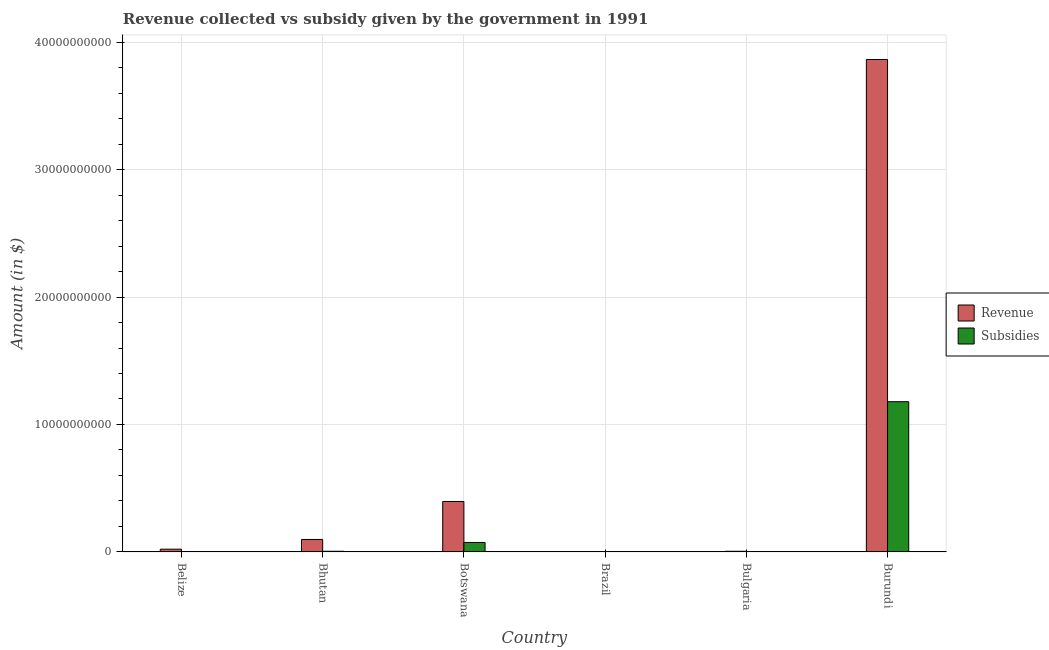How many different coloured bars are there?
Ensure brevity in your answer.  2. How many groups of bars are there?
Your response must be concise. 6. Are the number of bars per tick equal to the number of legend labels?
Provide a short and direct response. Yes. Are the number of bars on each tick of the X-axis equal?
Give a very brief answer. Yes. What is the label of the 1st group of bars from the left?
Your answer should be very brief. Belize. In how many cases, is the number of bars for a given country not equal to the number of legend labels?
Keep it short and to the point. 0. What is the amount of subsidies given in Bhutan?
Keep it short and to the point. 5.12e+07. Across all countries, what is the maximum amount of subsidies given?
Offer a very short reply. 1.18e+1. Across all countries, what is the minimum amount of revenue collected?
Give a very brief answer. 1.25e+07. In which country was the amount of revenue collected maximum?
Ensure brevity in your answer.  Burundi. What is the total amount of revenue collected in the graph?
Provide a short and direct response. 4.38e+1. What is the difference between the amount of revenue collected in Belize and that in Burundi?
Ensure brevity in your answer.  -3.84e+1. What is the difference between the amount of subsidies given in Botswana and the amount of revenue collected in Belize?
Your answer should be very brief. 5.28e+08. What is the average amount of subsidies given per country?
Make the answer very short. 2.10e+09. What is the difference between the amount of revenue collected and amount of subsidies given in Bhutan?
Give a very brief answer. 9.25e+08. What is the ratio of the amount of subsidies given in Belize to that in Botswana?
Your response must be concise. 0.02. Is the amount of subsidies given in Bhutan less than that in Brazil?
Offer a terse response. No. What is the difference between the highest and the second highest amount of subsidies given?
Your answer should be very brief. 1.10e+1. What is the difference between the highest and the lowest amount of revenue collected?
Keep it short and to the point. 3.86e+1. In how many countries, is the amount of subsidies given greater than the average amount of subsidies given taken over all countries?
Make the answer very short. 1. Is the sum of the amount of subsidies given in Bulgaria and Burundi greater than the maximum amount of revenue collected across all countries?
Offer a terse response. No. What does the 1st bar from the left in Bhutan represents?
Your answer should be compact. Revenue. What does the 2nd bar from the right in Botswana represents?
Your answer should be very brief. Revenue. How many bars are there?
Offer a very short reply. 12. Are all the bars in the graph horizontal?
Offer a terse response. No. Are the values on the major ticks of Y-axis written in scientific E-notation?
Give a very brief answer. No. Does the graph contain grids?
Keep it short and to the point. Yes. Where does the legend appear in the graph?
Offer a terse response. Center right. What is the title of the graph?
Provide a succinct answer. Revenue collected vs subsidy given by the government in 1991. Does "International Visitors" appear as one of the legend labels in the graph?
Ensure brevity in your answer.  No. What is the label or title of the X-axis?
Give a very brief answer. Country. What is the label or title of the Y-axis?
Give a very brief answer. Amount (in $). What is the Amount (in $) of Revenue in Belize?
Your answer should be very brief. 2.14e+08. What is the Amount (in $) in Subsidies in Belize?
Ensure brevity in your answer.  1.41e+07. What is the Amount (in $) in Revenue in Bhutan?
Provide a short and direct response. 9.76e+08. What is the Amount (in $) of Subsidies in Bhutan?
Provide a short and direct response. 5.12e+07. What is the Amount (in $) of Revenue in Botswana?
Your response must be concise. 3.96e+09. What is the Amount (in $) of Subsidies in Botswana?
Give a very brief answer. 7.42e+08. What is the Amount (in $) in Revenue in Brazil?
Keep it short and to the point. 1.25e+07. What is the Amount (in $) in Subsidies in Brazil?
Offer a terse response. 7.89e+06. What is the Amount (in $) of Revenue in Bulgaria?
Provide a short and direct response. 4.94e+07. What is the Amount (in $) in Subsidies in Bulgaria?
Give a very brief answer. 2.72e+07. What is the Amount (in $) of Revenue in Burundi?
Provide a succinct answer. 3.86e+1. What is the Amount (in $) in Subsidies in Burundi?
Keep it short and to the point. 1.18e+1. Across all countries, what is the maximum Amount (in $) of Revenue?
Make the answer very short. 3.86e+1. Across all countries, what is the maximum Amount (in $) in Subsidies?
Keep it short and to the point. 1.18e+1. Across all countries, what is the minimum Amount (in $) in Revenue?
Your response must be concise. 1.25e+07. Across all countries, what is the minimum Amount (in $) of Subsidies?
Keep it short and to the point. 7.89e+06. What is the total Amount (in $) of Revenue in the graph?
Provide a succinct answer. 4.38e+1. What is the total Amount (in $) of Subsidies in the graph?
Give a very brief answer. 1.26e+1. What is the difference between the Amount (in $) of Revenue in Belize and that in Bhutan?
Keep it short and to the point. -7.63e+08. What is the difference between the Amount (in $) in Subsidies in Belize and that in Bhutan?
Keep it short and to the point. -3.71e+07. What is the difference between the Amount (in $) of Revenue in Belize and that in Botswana?
Make the answer very short. -3.74e+09. What is the difference between the Amount (in $) in Subsidies in Belize and that in Botswana?
Offer a terse response. -7.28e+08. What is the difference between the Amount (in $) of Revenue in Belize and that in Brazil?
Your response must be concise. 2.01e+08. What is the difference between the Amount (in $) of Subsidies in Belize and that in Brazil?
Ensure brevity in your answer.  6.24e+06. What is the difference between the Amount (in $) in Revenue in Belize and that in Bulgaria?
Offer a terse response. 1.64e+08. What is the difference between the Amount (in $) of Subsidies in Belize and that in Bulgaria?
Provide a short and direct response. -1.31e+07. What is the difference between the Amount (in $) of Revenue in Belize and that in Burundi?
Ensure brevity in your answer.  -3.84e+1. What is the difference between the Amount (in $) in Subsidies in Belize and that in Burundi?
Keep it short and to the point. -1.18e+1. What is the difference between the Amount (in $) in Revenue in Bhutan and that in Botswana?
Give a very brief answer. -2.98e+09. What is the difference between the Amount (in $) in Subsidies in Bhutan and that in Botswana?
Provide a short and direct response. -6.91e+08. What is the difference between the Amount (in $) in Revenue in Bhutan and that in Brazil?
Provide a succinct answer. 9.64e+08. What is the difference between the Amount (in $) in Subsidies in Bhutan and that in Brazil?
Provide a short and direct response. 4.33e+07. What is the difference between the Amount (in $) of Revenue in Bhutan and that in Bulgaria?
Provide a succinct answer. 9.27e+08. What is the difference between the Amount (in $) in Subsidies in Bhutan and that in Bulgaria?
Your response must be concise. 2.40e+07. What is the difference between the Amount (in $) in Revenue in Bhutan and that in Burundi?
Ensure brevity in your answer.  -3.77e+1. What is the difference between the Amount (in $) of Subsidies in Bhutan and that in Burundi?
Your answer should be very brief. -1.17e+1. What is the difference between the Amount (in $) in Revenue in Botswana and that in Brazil?
Offer a terse response. 3.94e+09. What is the difference between the Amount (in $) in Subsidies in Botswana and that in Brazil?
Provide a succinct answer. 7.34e+08. What is the difference between the Amount (in $) of Revenue in Botswana and that in Bulgaria?
Offer a terse response. 3.91e+09. What is the difference between the Amount (in $) of Subsidies in Botswana and that in Bulgaria?
Give a very brief answer. 7.15e+08. What is the difference between the Amount (in $) of Revenue in Botswana and that in Burundi?
Provide a succinct answer. -3.47e+1. What is the difference between the Amount (in $) in Subsidies in Botswana and that in Burundi?
Ensure brevity in your answer.  -1.10e+1. What is the difference between the Amount (in $) of Revenue in Brazil and that in Bulgaria?
Your answer should be compact. -3.69e+07. What is the difference between the Amount (in $) in Subsidies in Brazil and that in Bulgaria?
Offer a very short reply. -1.93e+07. What is the difference between the Amount (in $) in Revenue in Brazil and that in Burundi?
Provide a succinct answer. -3.86e+1. What is the difference between the Amount (in $) in Subsidies in Brazil and that in Burundi?
Make the answer very short. -1.18e+1. What is the difference between the Amount (in $) of Revenue in Bulgaria and that in Burundi?
Provide a succinct answer. -3.86e+1. What is the difference between the Amount (in $) in Subsidies in Bulgaria and that in Burundi?
Your answer should be very brief. -1.18e+1. What is the difference between the Amount (in $) in Revenue in Belize and the Amount (in $) in Subsidies in Bhutan?
Keep it short and to the point. 1.63e+08. What is the difference between the Amount (in $) of Revenue in Belize and the Amount (in $) of Subsidies in Botswana?
Provide a short and direct response. -5.28e+08. What is the difference between the Amount (in $) in Revenue in Belize and the Amount (in $) in Subsidies in Brazil?
Offer a terse response. 2.06e+08. What is the difference between the Amount (in $) of Revenue in Belize and the Amount (in $) of Subsidies in Bulgaria?
Ensure brevity in your answer.  1.87e+08. What is the difference between the Amount (in $) of Revenue in Belize and the Amount (in $) of Subsidies in Burundi?
Keep it short and to the point. -1.16e+1. What is the difference between the Amount (in $) in Revenue in Bhutan and the Amount (in $) in Subsidies in Botswana?
Your response must be concise. 2.34e+08. What is the difference between the Amount (in $) of Revenue in Bhutan and the Amount (in $) of Subsidies in Brazil?
Your response must be concise. 9.69e+08. What is the difference between the Amount (in $) in Revenue in Bhutan and the Amount (in $) in Subsidies in Bulgaria?
Your answer should be compact. 9.49e+08. What is the difference between the Amount (in $) of Revenue in Bhutan and the Amount (in $) of Subsidies in Burundi?
Your response must be concise. -1.08e+1. What is the difference between the Amount (in $) of Revenue in Botswana and the Amount (in $) of Subsidies in Brazil?
Give a very brief answer. 3.95e+09. What is the difference between the Amount (in $) in Revenue in Botswana and the Amount (in $) in Subsidies in Bulgaria?
Make the answer very short. 3.93e+09. What is the difference between the Amount (in $) in Revenue in Botswana and the Amount (in $) in Subsidies in Burundi?
Keep it short and to the point. -7.83e+09. What is the difference between the Amount (in $) in Revenue in Brazil and the Amount (in $) in Subsidies in Bulgaria?
Provide a succinct answer. -1.47e+07. What is the difference between the Amount (in $) in Revenue in Brazil and the Amount (in $) in Subsidies in Burundi?
Provide a succinct answer. -1.18e+1. What is the difference between the Amount (in $) of Revenue in Bulgaria and the Amount (in $) of Subsidies in Burundi?
Offer a very short reply. -1.17e+1. What is the average Amount (in $) of Revenue per country?
Provide a short and direct response. 7.31e+09. What is the average Amount (in $) of Subsidies per country?
Provide a short and direct response. 2.10e+09. What is the difference between the Amount (in $) of Revenue and Amount (in $) of Subsidies in Belize?
Your answer should be compact. 2.00e+08. What is the difference between the Amount (in $) of Revenue and Amount (in $) of Subsidies in Bhutan?
Your answer should be compact. 9.25e+08. What is the difference between the Amount (in $) in Revenue and Amount (in $) in Subsidies in Botswana?
Provide a short and direct response. 3.22e+09. What is the difference between the Amount (in $) in Revenue and Amount (in $) in Subsidies in Brazil?
Your answer should be very brief. 4.64e+06. What is the difference between the Amount (in $) in Revenue and Amount (in $) in Subsidies in Bulgaria?
Offer a very short reply. 2.22e+07. What is the difference between the Amount (in $) of Revenue and Amount (in $) of Subsidies in Burundi?
Your response must be concise. 2.69e+1. What is the ratio of the Amount (in $) of Revenue in Belize to that in Bhutan?
Make the answer very short. 0.22. What is the ratio of the Amount (in $) in Subsidies in Belize to that in Bhutan?
Ensure brevity in your answer.  0.28. What is the ratio of the Amount (in $) in Revenue in Belize to that in Botswana?
Provide a short and direct response. 0.05. What is the ratio of the Amount (in $) in Subsidies in Belize to that in Botswana?
Your response must be concise. 0.02. What is the ratio of the Amount (in $) in Revenue in Belize to that in Brazil?
Offer a terse response. 17.07. What is the ratio of the Amount (in $) of Subsidies in Belize to that in Brazil?
Provide a succinct answer. 1.79. What is the ratio of the Amount (in $) in Revenue in Belize to that in Bulgaria?
Your response must be concise. 4.33. What is the ratio of the Amount (in $) of Subsidies in Belize to that in Bulgaria?
Give a very brief answer. 0.52. What is the ratio of the Amount (in $) of Revenue in Belize to that in Burundi?
Your response must be concise. 0.01. What is the ratio of the Amount (in $) in Subsidies in Belize to that in Burundi?
Your answer should be compact. 0. What is the ratio of the Amount (in $) of Revenue in Bhutan to that in Botswana?
Your answer should be compact. 0.25. What is the ratio of the Amount (in $) in Subsidies in Bhutan to that in Botswana?
Your response must be concise. 0.07. What is the ratio of the Amount (in $) of Revenue in Bhutan to that in Brazil?
Offer a very short reply. 77.92. What is the ratio of the Amount (in $) in Subsidies in Bhutan to that in Brazil?
Your response must be concise. 6.49. What is the ratio of the Amount (in $) in Revenue in Bhutan to that in Bulgaria?
Your answer should be compact. 19.77. What is the ratio of the Amount (in $) in Subsidies in Bhutan to that in Bulgaria?
Your response must be concise. 1.88. What is the ratio of the Amount (in $) in Revenue in Bhutan to that in Burundi?
Your response must be concise. 0.03. What is the ratio of the Amount (in $) of Subsidies in Bhutan to that in Burundi?
Your response must be concise. 0. What is the ratio of the Amount (in $) of Revenue in Botswana to that in Brazil?
Offer a very short reply. 315.8. What is the ratio of the Amount (in $) of Subsidies in Botswana to that in Brazil?
Keep it short and to the point. 93.97. What is the ratio of the Amount (in $) in Revenue in Botswana to that in Bulgaria?
Offer a terse response. 80.12. What is the ratio of the Amount (in $) of Subsidies in Botswana to that in Bulgaria?
Give a very brief answer. 27.26. What is the ratio of the Amount (in $) of Revenue in Botswana to that in Burundi?
Your answer should be compact. 0.1. What is the ratio of the Amount (in $) in Subsidies in Botswana to that in Burundi?
Your answer should be very brief. 0.06. What is the ratio of the Amount (in $) in Revenue in Brazil to that in Bulgaria?
Provide a succinct answer. 0.25. What is the ratio of the Amount (in $) in Subsidies in Brazil to that in Bulgaria?
Provide a succinct answer. 0.29. What is the ratio of the Amount (in $) of Subsidies in Brazil to that in Burundi?
Your answer should be compact. 0. What is the ratio of the Amount (in $) in Revenue in Bulgaria to that in Burundi?
Your answer should be very brief. 0. What is the ratio of the Amount (in $) of Subsidies in Bulgaria to that in Burundi?
Provide a short and direct response. 0. What is the difference between the highest and the second highest Amount (in $) in Revenue?
Give a very brief answer. 3.47e+1. What is the difference between the highest and the second highest Amount (in $) in Subsidies?
Your response must be concise. 1.10e+1. What is the difference between the highest and the lowest Amount (in $) of Revenue?
Offer a very short reply. 3.86e+1. What is the difference between the highest and the lowest Amount (in $) of Subsidies?
Your answer should be compact. 1.18e+1. 